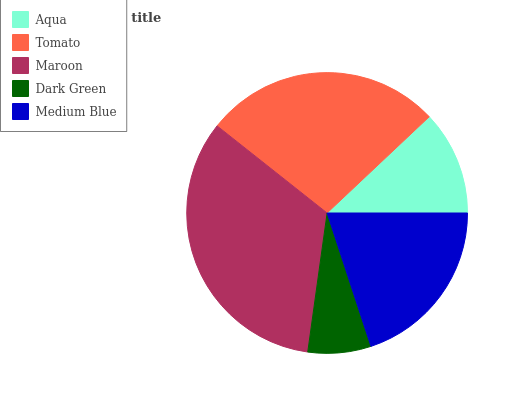Is Dark Green the minimum?
Answer yes or no. Yes. Is Maroon the maximum?
Answer yes or no. Yes. Is Tomato the minimum?
Answer yes or no. No. Is Tomato the maximum?
Answer yes or no. No. Is Tomato greater than Aqua?
Answer yes or no. Yes. Is Aqua less than Tomato?
Answer yes or no. Yes. Is Aqua greater than Tomato?
Answer yes or no. No. Is Tomato less than Aqua?
Answer yes or no. No. Is Medium Blue the high median?
Answer yes or no. Yes. Is Medium Blue the low median?
Answer yes or no. Yes. Is Aqua the high median?
Answer yes or no. No. Is Dark Green the low median?
Answer yes or no. No. 